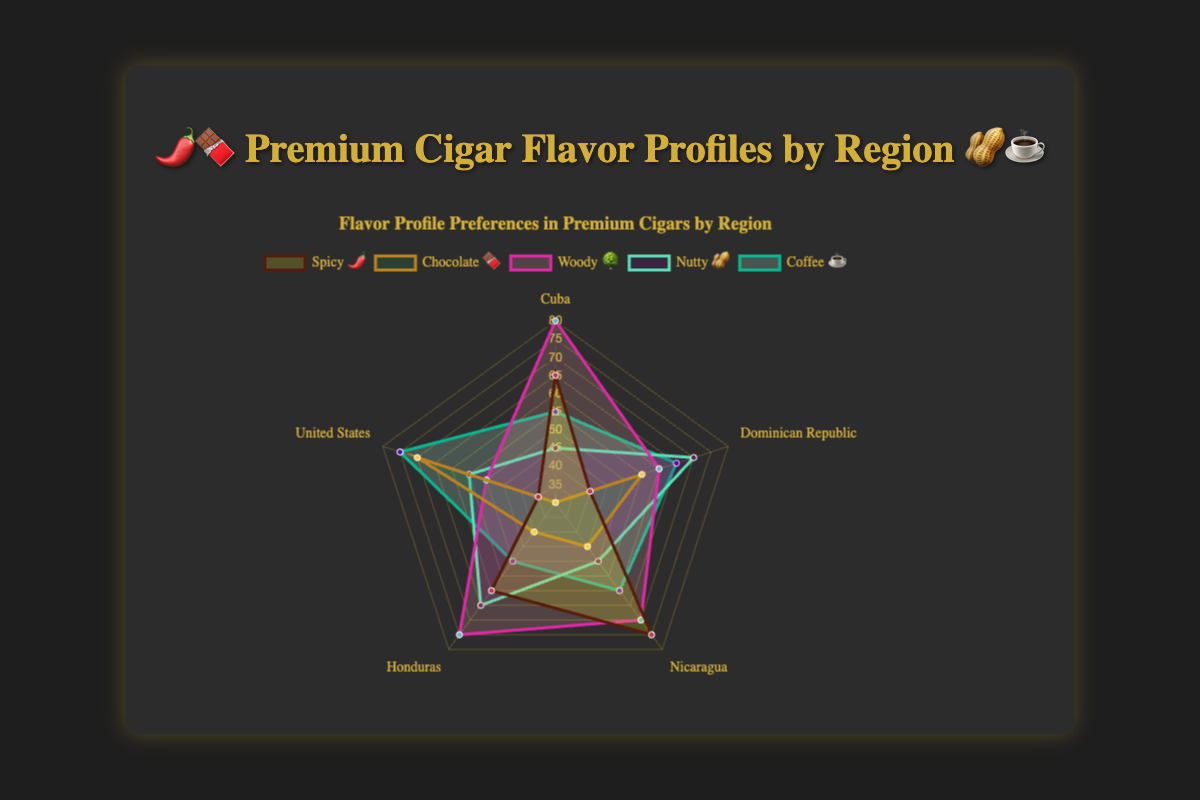What region has the highest preference for Spicy 🌶️ flavor? The radar chart shows preferences for Spicy 🌶️ flavor across various regions. The highest value for Spicy 🌶️ is 75, which corresponds to Nicaragua.
Answer: Nicaragua Which region has the lowest preference for Chocolate 🍫 flavor? We need to look at the Chocolate 🍫 preferences across all regions. The lowest preference is 30, which is for Cuba.
Answer: Cuba Compare the preference for Nutty 🥜 flavor between the Dominican Republic and Honduras. Which region has a higher preference? Checking the radar chart, the preferences for Nutty 🥜 flavor are 70 for the Dominican Republic and 65 for Honduras. Therefore, the Dominican Republic has a higher preference.
Answer: Dominican Republic What is the average preference for Woody 🌳 flavor across all regions? The preferences for Woody 🌳 flavor are 80, 60, 70, 75, and 50. To find the average, add these values (80 + 60 + 70 + 75 + 50 = 335) and divide by 5. 335/5 = 67
Answer: 67 Is the preference for Coffee ☕ flavor higher in the United States or Cuba? Looking at the radar chart, Cuba has a preference of 55 for Coffee ☕, and the United States has a preference of 75. Hence, the preference is higher in the United States.
Answer: United States Which region has the most balanced preference (least variance) across all flavor profiles? To determine this, you would need to calculate the variance of the preferences across all profiles for each region. By comparison, the United States appears to have more balanced preferences, as the differences between their highest (Chocolate 🍫 70) and lowest (Spicy 🌶️ 35) preferences are less extreme.
Answer: United States What is the combined preference for Spicy 🌶️ and Chocolate 🍫 flavors in the Dominican Republic? The preference for Spicy 🌶️ is 40 and for Chocolate 🍫 is 55 in the Dominican Republic. The combined preference is 40 + 55 = 95
Answer: 95 Which flavor profile has the highest preference in Cuba? Examining the radar chart for Cuba, the highest preference values are 80 for Woody 🌳.
Answer: Woody 🌳 In which regions does the Nutty 🥜 flavor profile have a higher preference compared to Chocolate 🍫? To find this, compare Nutty 🥜 and Chocolate 🍫 preferences for all regions: Cuba (45 vs 30), Dominican Republic (70 vs 55), Nicaragua (50 vs 45), Honduras (65 vs 40), United States (55 vs 70). The preferences for Nutty 🥜 are higher in Cuba, Dominican Republic, and Honduras.
Answer: Cuba, Dominican Republic, Honduras 